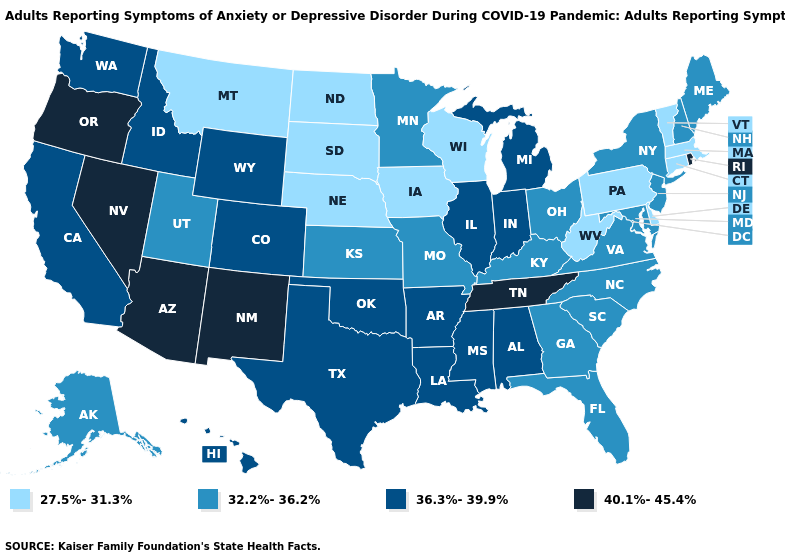Among the states that border Missouri , which have the lowest value?
Answer briefly. Iowa, Nebraska. Which states have the highest value in the USA?
Write a very short answer. Arizona, Nevada, New Mexico, Oregon, Rhode Island, Tennessee. Name the states that have a value in the range 32.2%-36.2%?
Give a very brief answer. Alaska, Florida, Georgia, Kansas, Kentucky, Maine, Maryland, Minnesota, Missouri, New Hampshire, New Jersey, New York, North Carolina, Ohio, South Carolina, Utah, Virginia. Name the states that have a value in the range 40.1%-45.4%?
Answer briefly. Arizona, Nevada, New Mexico, Oregon, Rhode Island, Tennessee. What is the value of Alaska?
Answer briefly. 32.2%-36.2%. Which states hav the highest value in the West?
Keep it brief. Arizona, Nevada, New Mexico, Oregon. Name the states that have a value in the range 27.5%-31.3%?
Keep it brief. Connecticut, Delaware, Iowa, Massachusetts, Montana, Nebraska, North Dakota, Pennsylvania, South Dakota, Vermont, West Virginia, Wisconsin. What is the highest value in the MidWest ?
Answer briefly. 36.3%-39.9%. Does Nebraska have a lower value than Delaware?
Be succinct. No. How many symbols are there in the legend?
Short answer required. 4. What is the value of California?
Short answer required. 36.3%-39.9%. Name the states that have a value in the range 40.1%-45.4%?
Answer briefly. Arizona, Nevada, New Mexico, Oregon, Rhode Island, Tennessee. What is the value of Tennessee?
Keep it brief. 40.1%-45.4%. What is the highest value in states that border Rhode Island?
Write a very short answer. 27.5%-31.3%. What is the value of Washington?
Quick response, please. 36.3%-39.9%. 